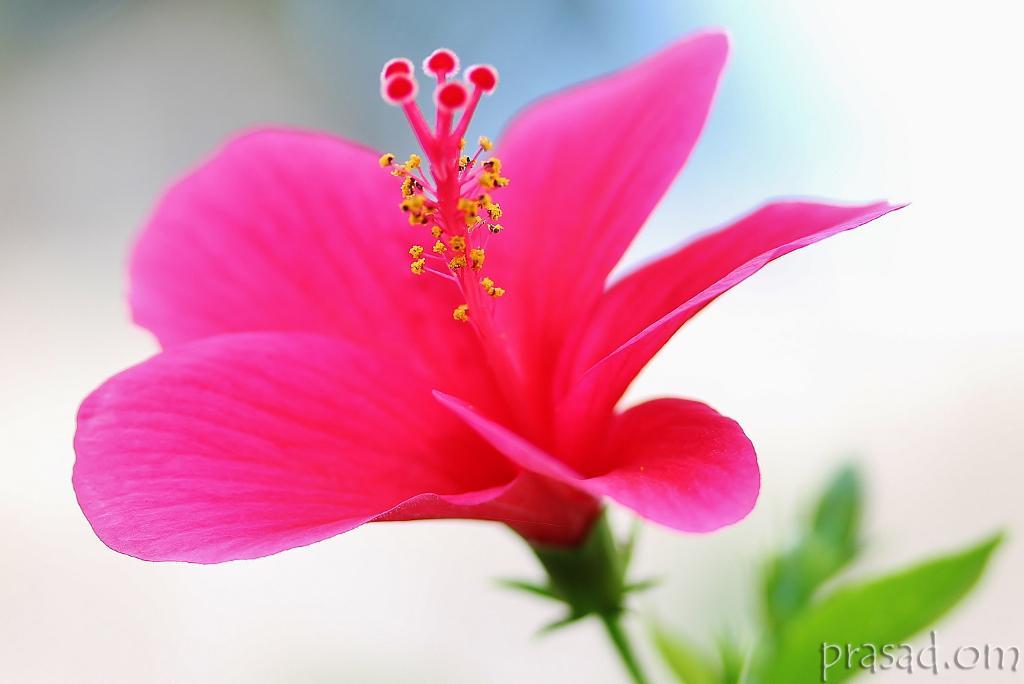Please provide a concise description of this image. By seeing this image we can say a photograph of the flower was taken. Flower is having two colors pink and yellow, the leaves are green in color. A text was written on the image. 